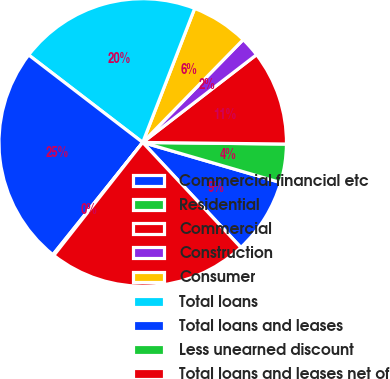Convert chart. <chart><loc_0><loc_0><loc_500><loc_500><pie_chart><fcel>Commercial financial etc<fcel>Residential<fcel>Commercial<fcel>Construction<fcel>Consumer<fcel>Total loans<fcel>Total loans and leases<fcel>Less unearned discount<fcel>Total loans and leases net of<nl><fcel>8.53%<fcel>4.33%<fcel>10.63%<fcel>2.23%<fcel>6.43%<fcel>20.47%<fcel>24.67%<fcel>0.13%<fcel>22.57%<nl></chart> 